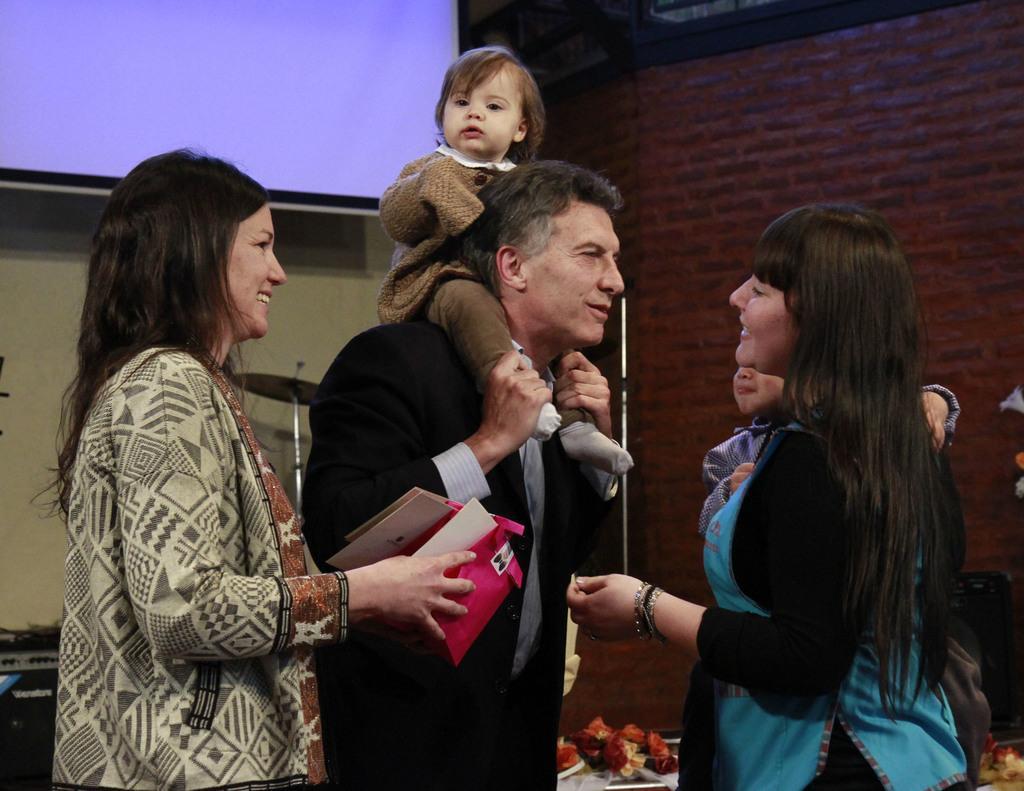Please provide a concise description of this image. In this image we can see a man holding a baby and we can see a woman with a kid. We can also see the other woman on the left holding an object. In the background we can see the screen, brick wall, mike stand and also musical instrument. 